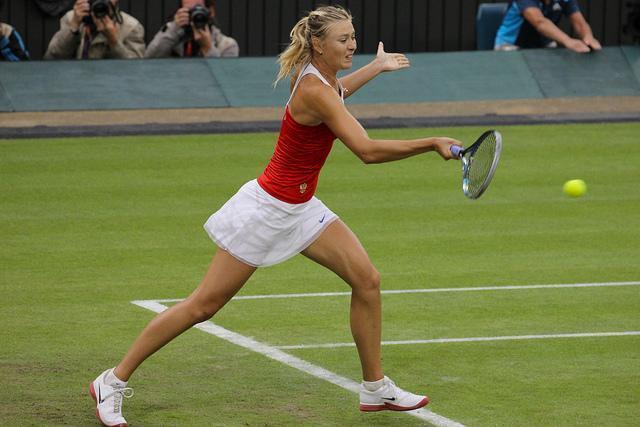What type of shot is the woman hitting?
Make your selection and explain in format: 'Answer: answer
Rationale: rationale.'
Options: Slice, serve, forehand, backhand. Answer: forehand.
Rationale: The shot uses the forehand. 